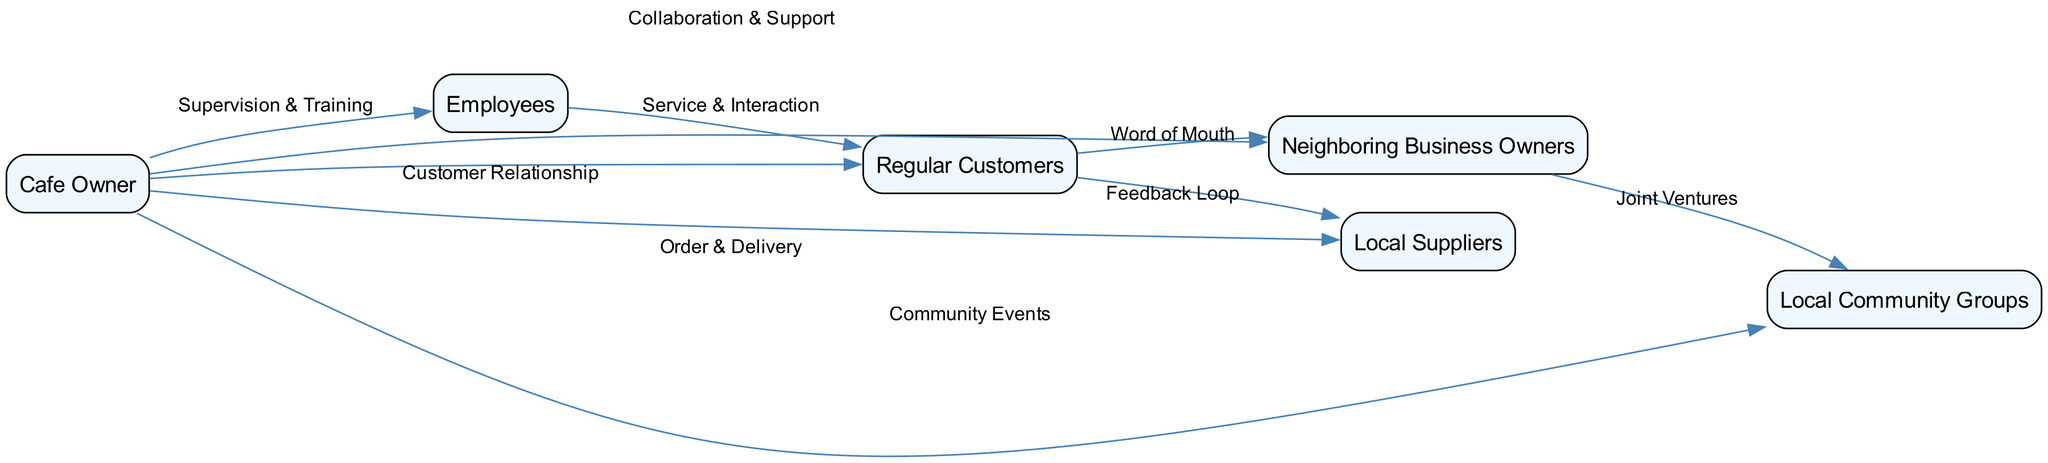What is the total number of nodes in the diagram? The diagram consists of six nodes: Cafe Owner, Employees, Regular Customers, Local Suppliers, Neighboring Business Owners, and Local Community Groups. Counting these nodes gives a total of six.
Answer: 6 What is the relationship between the owner and local suppliers? The diagram indicates a relationship labeled "Order & Delivery" between the Cafe Owner and Local Suppliers, which implies a connection regarding the procurement of supplies for the cafe.
Answer: Order & Delivery Who primarily interacts with regular customers according to the diagram? Employees are shown to have a direct relationship labeled "Service & Interaction" with Regular Customers, indicating they are the primary point of interaction for service.
Answer: Employees How many edges connect the owner to other nodes? The Cafe Owner has five edges connecting to other nodes: Employees, Regular Customers, Local Suppliers, Neighboring Business Owners, and Local Community Groups. Therefore, there are five edges originating from the owner.
Answer: 5 Which group collaborates with neighboring business owners? The Local Community Groups are depicted as collaborating with Neighboring Business Owners through a relationship labeled "Joint Ventures." This indicates a partnership between these two groups.
Answer: Local Community Groups What type of feedback is depicted between regular customers and local suppliers? The diagram shows a relationship labeled "Feedback Loop" connecting Regular Customers to Local Suppliers, indicating an ongoing exchange of feedback regarding services or products.
Answer: Feedback Loop Which node has the highest number of outgoing edges? The Cafe Owner has five outgoing edges, connecting with various entities, while all other nodes have fewer, making the Cafe Owner the node with the highest number of outgoing edges in the diagram.
Answer: Cafe Owner What type of social interaction is shown between employees and regular customers? The relationship labeled "Service & Interaction" indicates that employees provide service and interact with regular customers, highlighting their role in the customer experience at the cafe.
Answer: Service & Interaction Which nodes are directly linked through word-of-mouth communication? Regular Customers are directly linked to Neighboring Business Owners through a relationship labeled "Word of Mouth," indicating this form of communication between the two.
Answer: Word of Mouth 